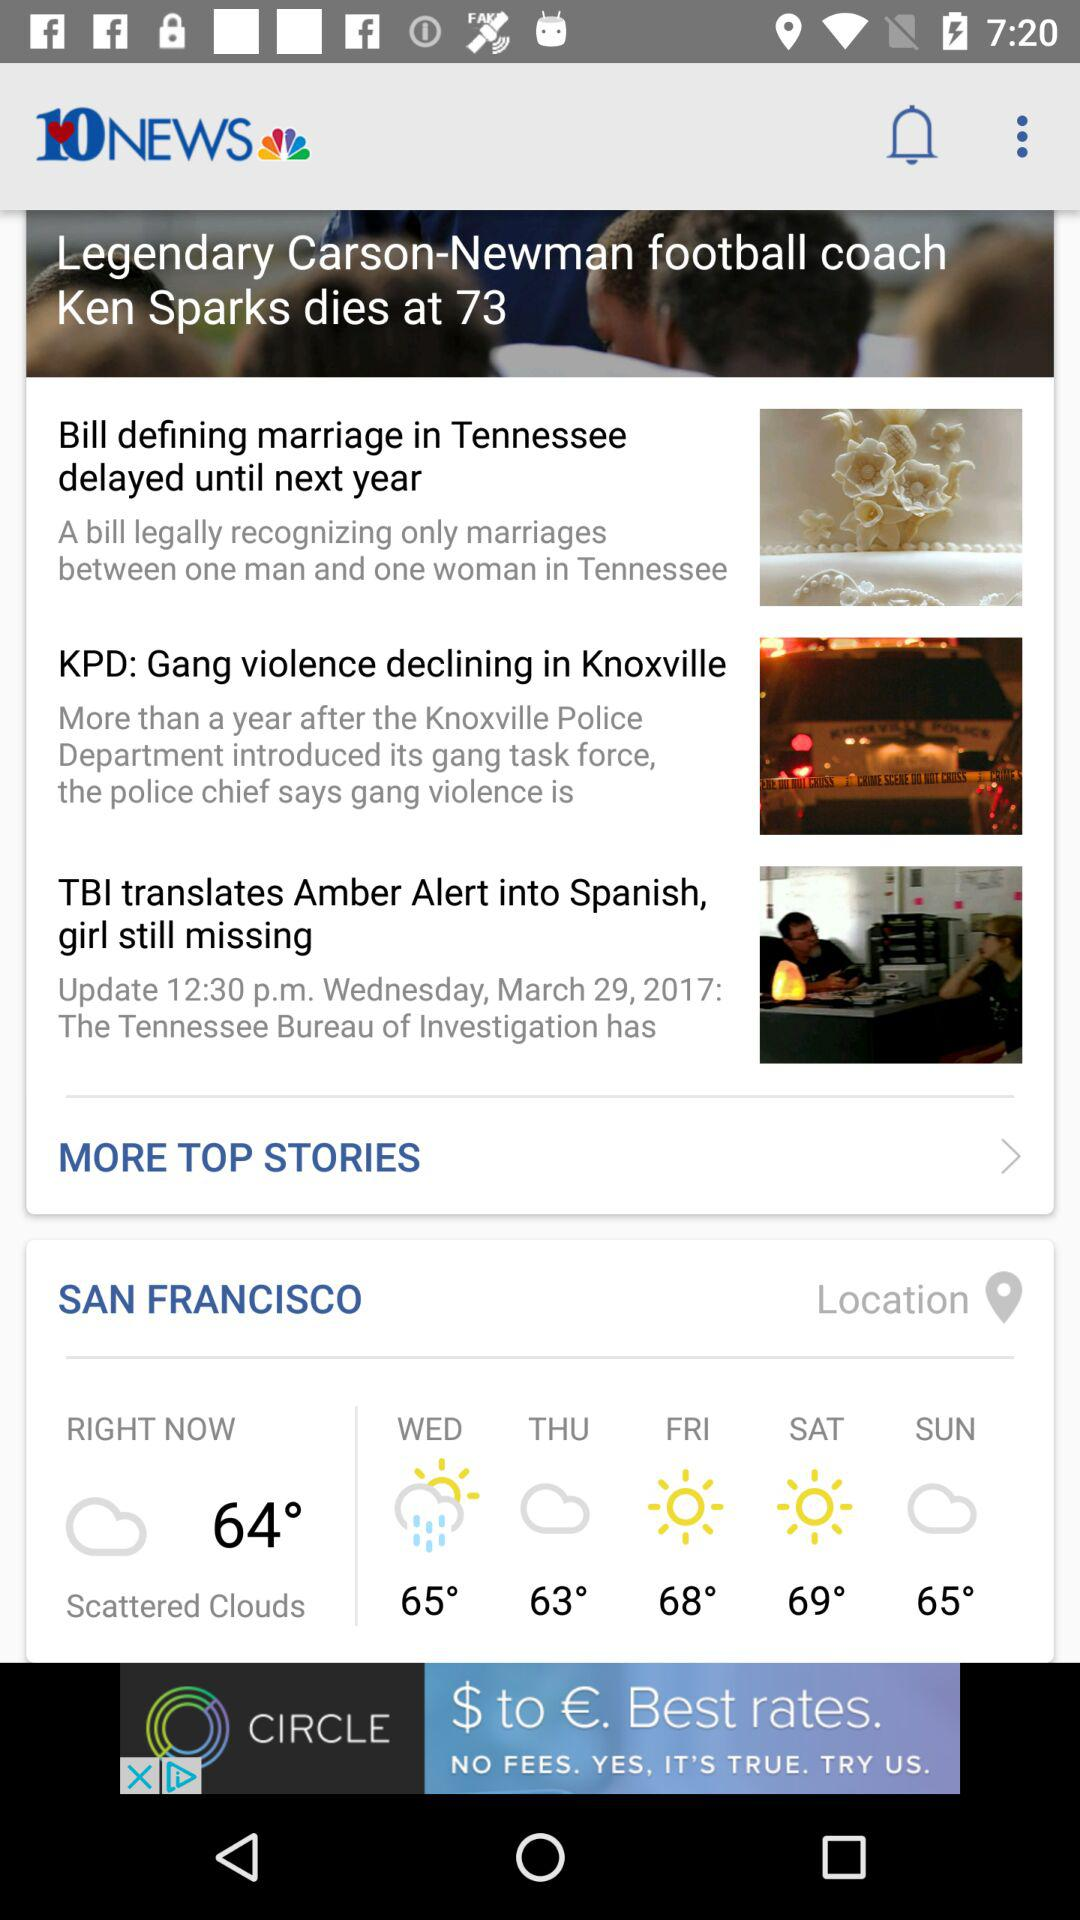What is the headline of the article? The headline is "Legendary Carson-Newman football coach Ken Sparks dies at 73". 